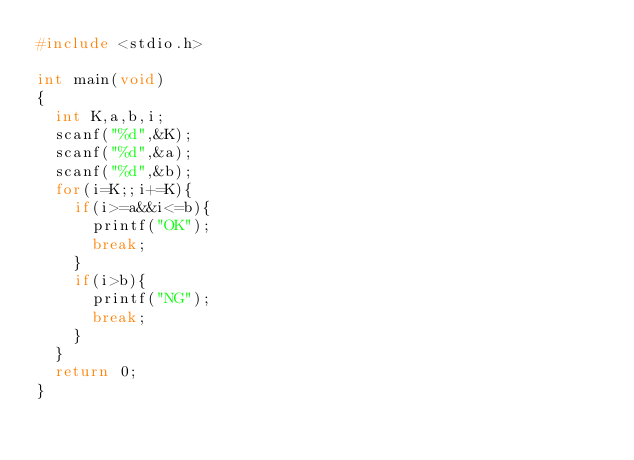<code> <loc_0><loc_0><loc_500><loc_500><_C_>#include <stdio.h>

int main(void)
{
	int K,a,b,i;
	scanf("%d",&K);
	scanf("%d",&a);
	scanf("%d",&b);
	for(i=K;;i+=K){
		if(i>=a&&i<=b){
			printf("OK");
			break;
		}
		if(i>b){
			printf("NG");
			break;
		}
	}
	return 0;
}</code> 